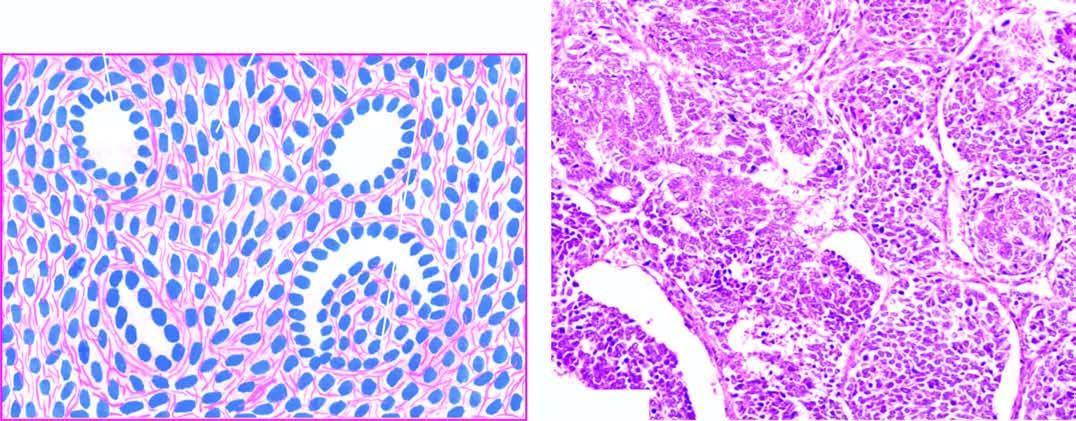s there predominance of small round to spindled sarcomatoid tumour cells?
Answer the question using a single word or phrase. Yes 